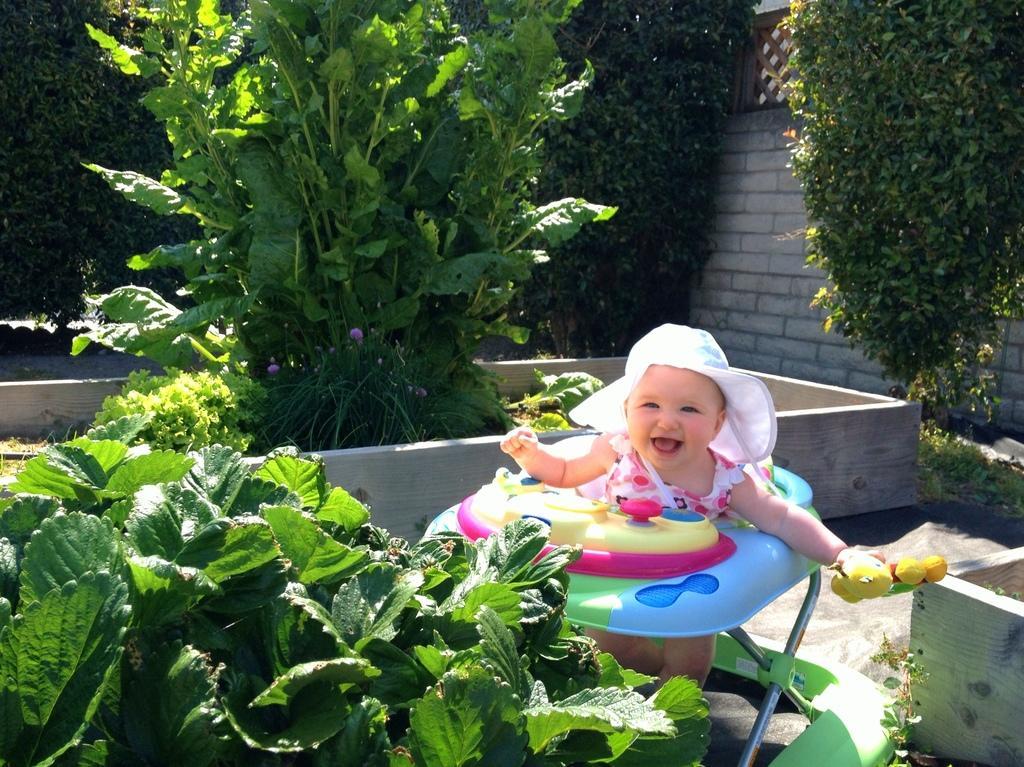In one or two sentences, can you explain what this image depicts? In this picture we can observe a baby smiling. We can observe white color hat on her head. There are some plants and trees on the ground. In the background we can observe a wall. 